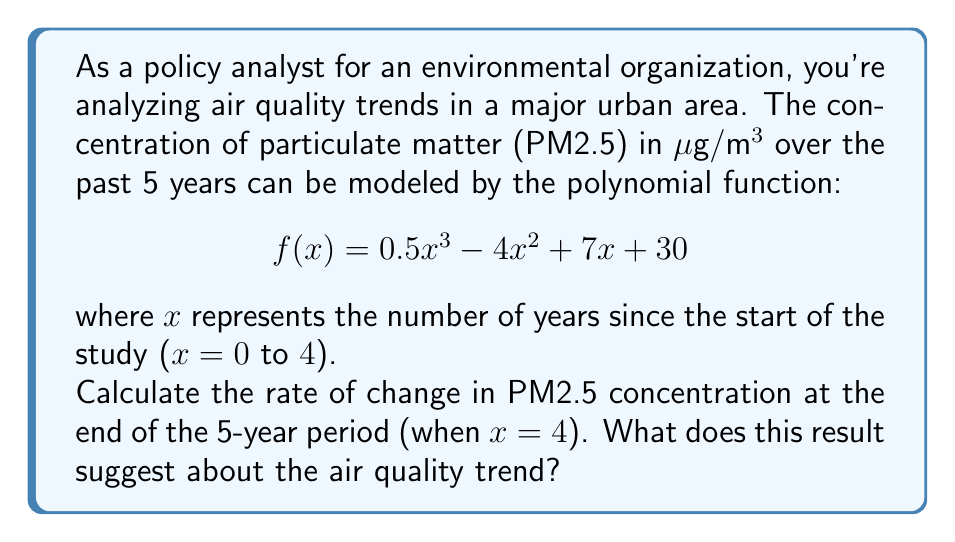Can you solve this math problem? To solve this problem, we need to follow these steps:

1) The rate of change is given by the first derivative of the function. Let's find $f'(x)$:

   $$f'(x) = \frac{d}{dx}(0.5x^3 - 4x^2 + 7x + 30)$$
   $$f'(x) = 1.5x^2 - 8x + 7$$

2) We need to evaluate $f'(x)$ at x = 4:

   $$f'(4) = 1.5(4)^2 - 8(4) + 7$$
   $$f'(4) = 1.5(16) - 32 + 7$$
   $$f'(4) = 24 - 32 + 7$$
   $$f'(4) = -1$$

3) Interpret the result:
   The rate of change at x = 4 is -1 μg/m³ per year. The negative value indicates that the PM2.5 concentration is decreasing at the end of the 5-year period.

This suggests that the air quality is improving, as the concentration of particulate matter is declining at a rate of 1 μg/m³ per year at the end of the study period.
Answer: The rate of change in PM2.5 concentration at the end of the 5-year period is -1 μg/m³ per year, suggesting an improving air quality trend. 